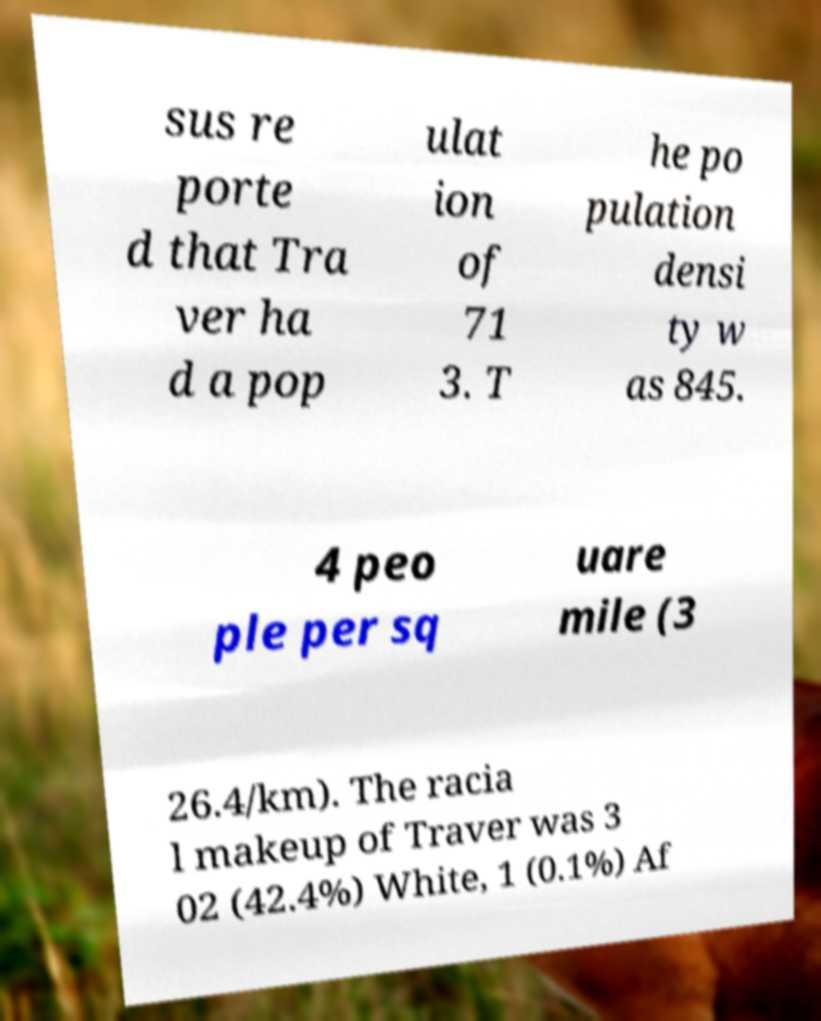Please identify and transcribe the text found in this image. sus re porte d that Tra ver ha d a pop ulat ion of 71 3. T he po pulation densi ty w as 845. 4 peo ple per sq uare mile (3 26.4/km). The racia l makeup of Traver was 3 02 (42.4%) White, 1 (0.1%) Af 